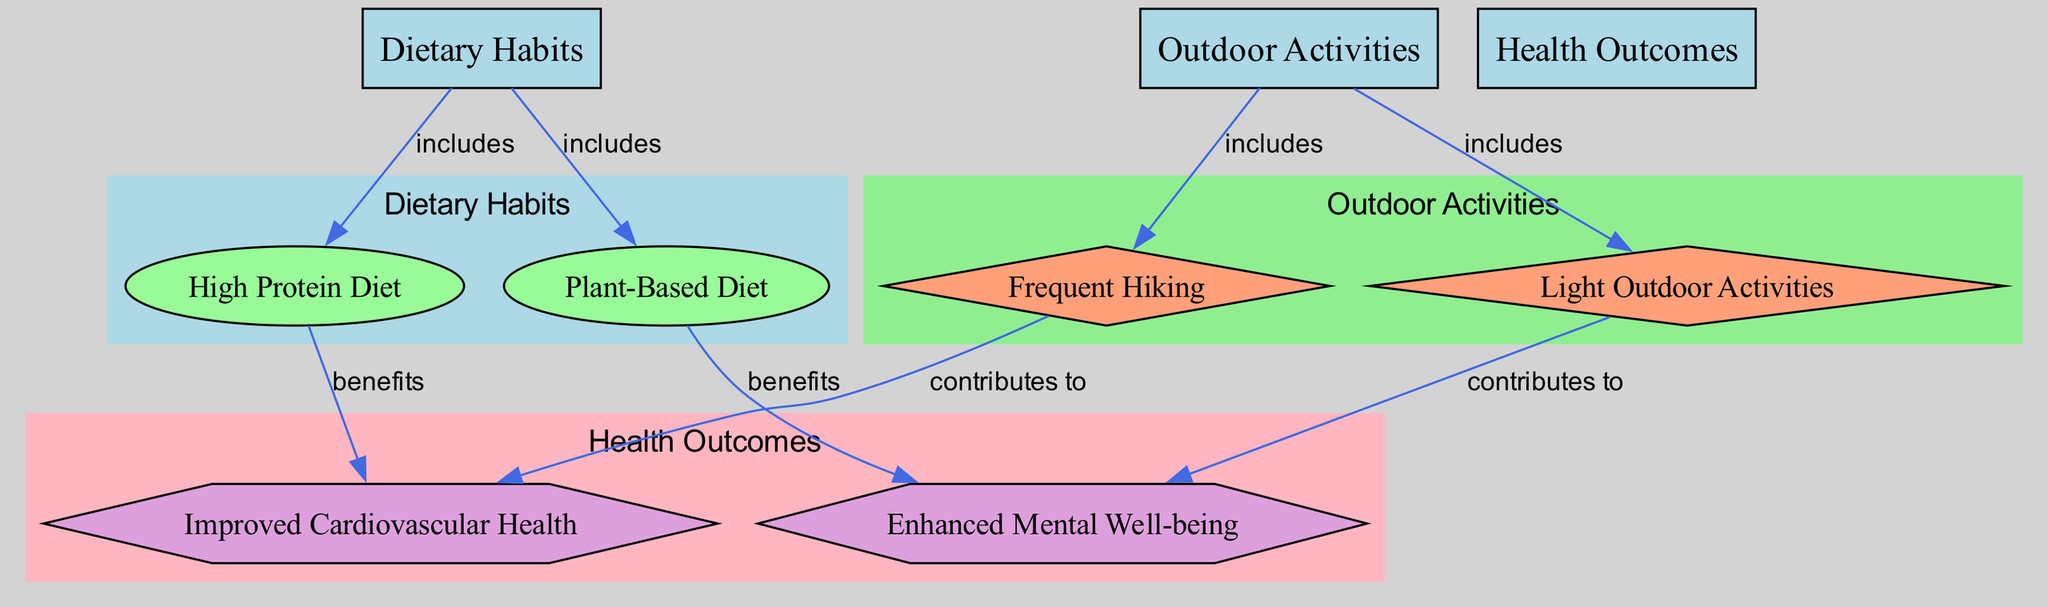What are the two categories represented in the diagram? The diagram includes nodes representing "Dietary Habits" and "Outdoor Activities". These are the two main categories shown that relate to health outcomes.
Answer: Dietary Habits, Outdoor Activities How many types of dietary habits are identified in the diagram? By examining the nodes related to dietary habits, we find two types: "High Protein Diet" and "Plant-Based Diet". Hence, there are two types of dietary habits identified.
Answer: 2 Which outdoor activity is associated with improved cardiovascular health? The "Frequent Hiking" node directly connects to the "Improved Cardiovascular Health" node via an edge labeled "contributes to". Thus, frequent hiking is associated with this health outcome.
Answer: Frequent Hiking What health outcome is linked with a plant-based diet? The diagram shows that "Plant-Based Diet" has an edge leading to "Enhanced Mental Well-being" labeled as "benefits". Therefore, this health outcome is linked with the plant-based diet.
Answer: Enhanced Mental Well-being Which dietary habit contributes to enhanced mental well-being? Analyzing the connections, we see that "Light Outdoor Activities" contributes to "Enhanced Mental Well-being". Although not directly diet-related, it suggests that engaging in certain outdoor activities can also be influenced by dietary habits.
Answer: Light Outdoor Activities 